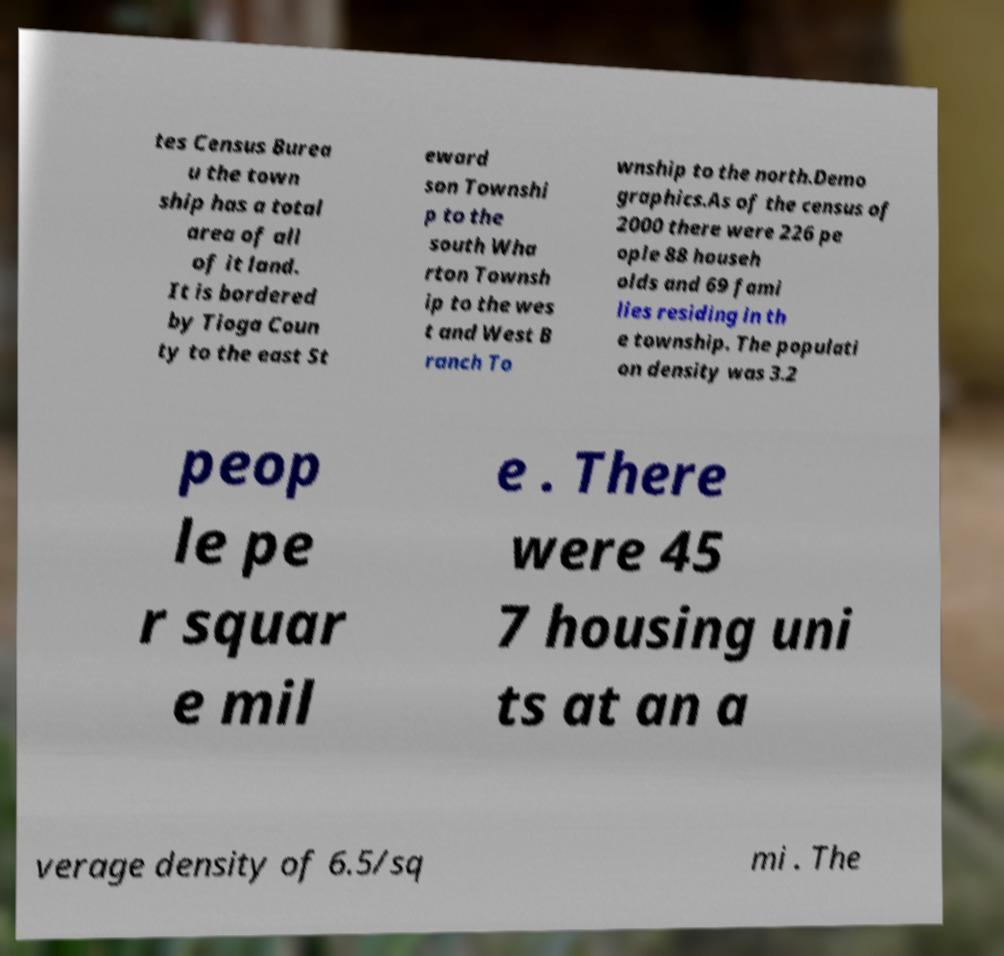Could you assist in decoding the text presented in this image and type it out clearly? tes Census Burea u the town ship has a total area of all of it land. It is bordered by Tioga Coun ty to the east St eward son Townshi p to the south Wha rton Townsh ip to the wes t and West B ranch To wnship to the north.Demo graphics.As of the census of 2000 there were 226 pe ople 88 househ olds and 69 fami lies residing in th e township. The populati on density was 3.2 peop le pe r squar e mil e . There were 45 7 housing uni ts at an a verage density of 6.5/sq mi . The 